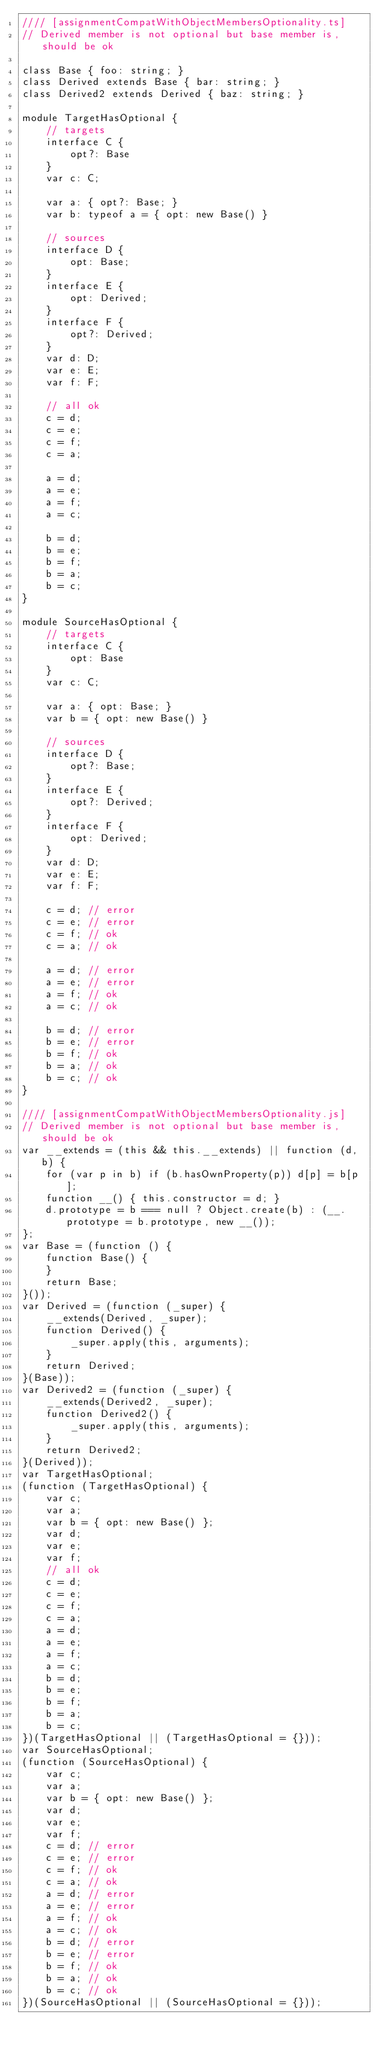<code> <loc_0><loc_0><loc_500><loc_500><_JavaScript_>//// [assignmentCompatWithObjectMembersOptionality.ts]
// Derived member is not optional but base member is, should be ok

class Base { foo: string; }
class Derived extends Base { bar: string; }
class Derived2 extends Derived { baz: string; }

module TargetHasOptional {
    // targets
    interface C {
        opt?: Base
    }
    var c: C;

    var a: { opt?: Base; }
    var b: typeof a = { opt: new Base() }

    // sources
    interface D {
        opt: Base;
    }
    interface E {
        opt: Derived;
    }
    interface F {
        opt?: Derived;
    }
    var d: D;
    var e: E;
    var f: F;

    // all ok
    c = d;
    c = e;
    c = f;
    c = a;

    a = d;
    a = e;
    a = f;
    a = c;

    b = d;
    b = e;
    b = f;
    b = a;
    b = c;
}

module SourceHasOptional {
    // targets
    interface C {
        opt: Base
    }
    var c: C;

    var a: { opt: Base; }
    var b = { opt: new Base() }

    // sources
    interface D {
        opt?: Base;
    }
    interface E {
        opt?: Derived;
    }
    interface F {
        opt: Derived;
    }
    var d: D;
    var e: E;
    var f: F;

    c = d; // error
    c = e; // error
    c = f; // ok
    c = a; // ok

    a = d; // error
    a = e; // error
    a = f; // ok
    a = c; // ok

    b = d; // error
    b = e; // error
    b = f; // ok
    b = a; // ok
    b = c; // ok
}

//// [assignmentCompatWithObjectMembersOptionality.js]
// Derived member is not optional but base member is, should be ok
var __extends = (this && this.__extends) || function (d, b) {
    for (var p in b) if (b.hasOwnProperty(p)) d[p] = b[p];
    function __() { this.constructor = d; }
    d.prototype = b === null ? Object.create(b) : (__.prototype = b.prototype, new __());
};
var Base = (function () {
    function Base() {
    }
    return Base;
}());
var Derived = (function (_super) {
    __extends(Derived, _super);
    function Derived() {
        _super.apply(this, arguments);
    }
    return Derived;
}(Base));
var Derived2 = (function (_super) {
    __extends(Derived2, _super);
    function Derived2() {
        _super.apply(this, arguments);
    }
    return Derived2;
}(Derived));
var TargetHasOptional;
(function (TargetHasOptional) {
    var c;
    var a;
    var b = { opt: new Base() };
    var d;
    var e;
    var f;
    // all ok
    c = d;
    c = e;
    c = f;
    c = a;
    a = d;
    a = e;
    a = f;
    a = c;
    b = d;
    b = e;
    b = f;
    b = a;
    b = c;
})(TargetHasOptional || (TargetHasOptional = {}));
var SourceHasOptional;
(function (SourceHasOptional) {
    var c;
    var a;
    var b = { opt: new Base() };
    var d;
    var e;
    var f;
    c = d; // error
    c = e; // error
    c = f; // ok
    c = a; // ok
    a = d; // error
    a = e; // error
    a = f; // ok
    a = c; // ok
    b = d; // error
    b = e; // error
    b = f; // ok
    b = a; // ok
    b = c; // ok
})(SourceHasOptional || (SourceHasOptional = {}));
</code> 